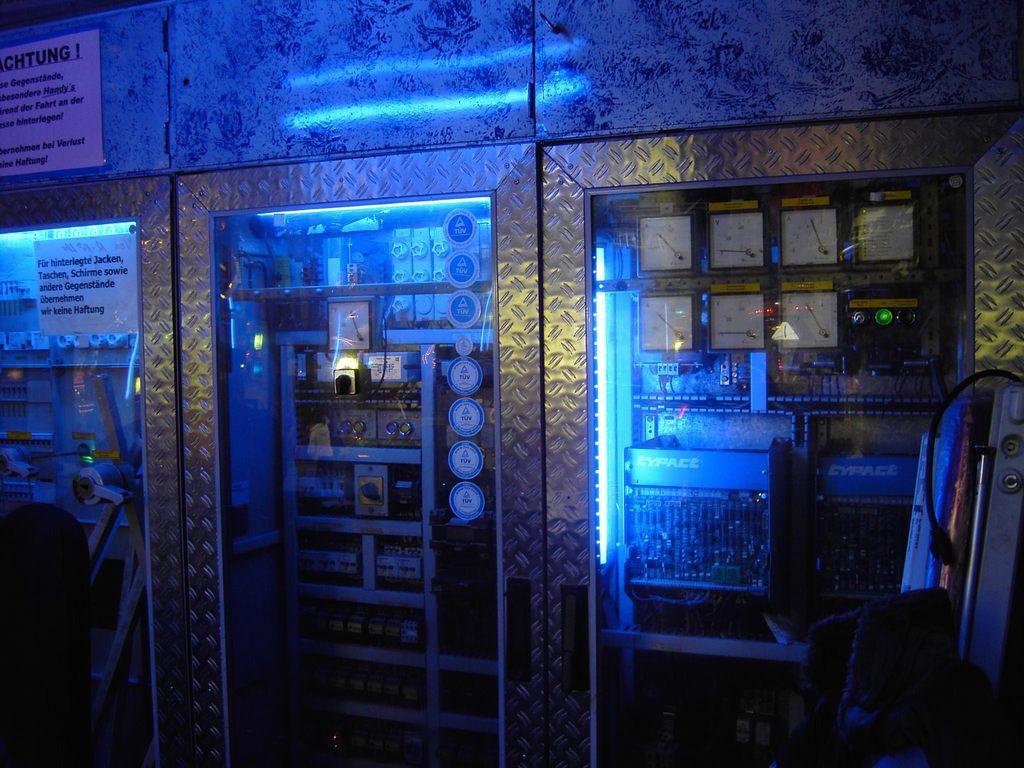In one or two sentences, can you explain what this image depicts? This picture seems to be clicked inside. In the center we can see the cupboards containing many number of items. On the right there is an object seems to be placed on the ground. On the left corner we can see the papers on which the text is printed on the papers. 